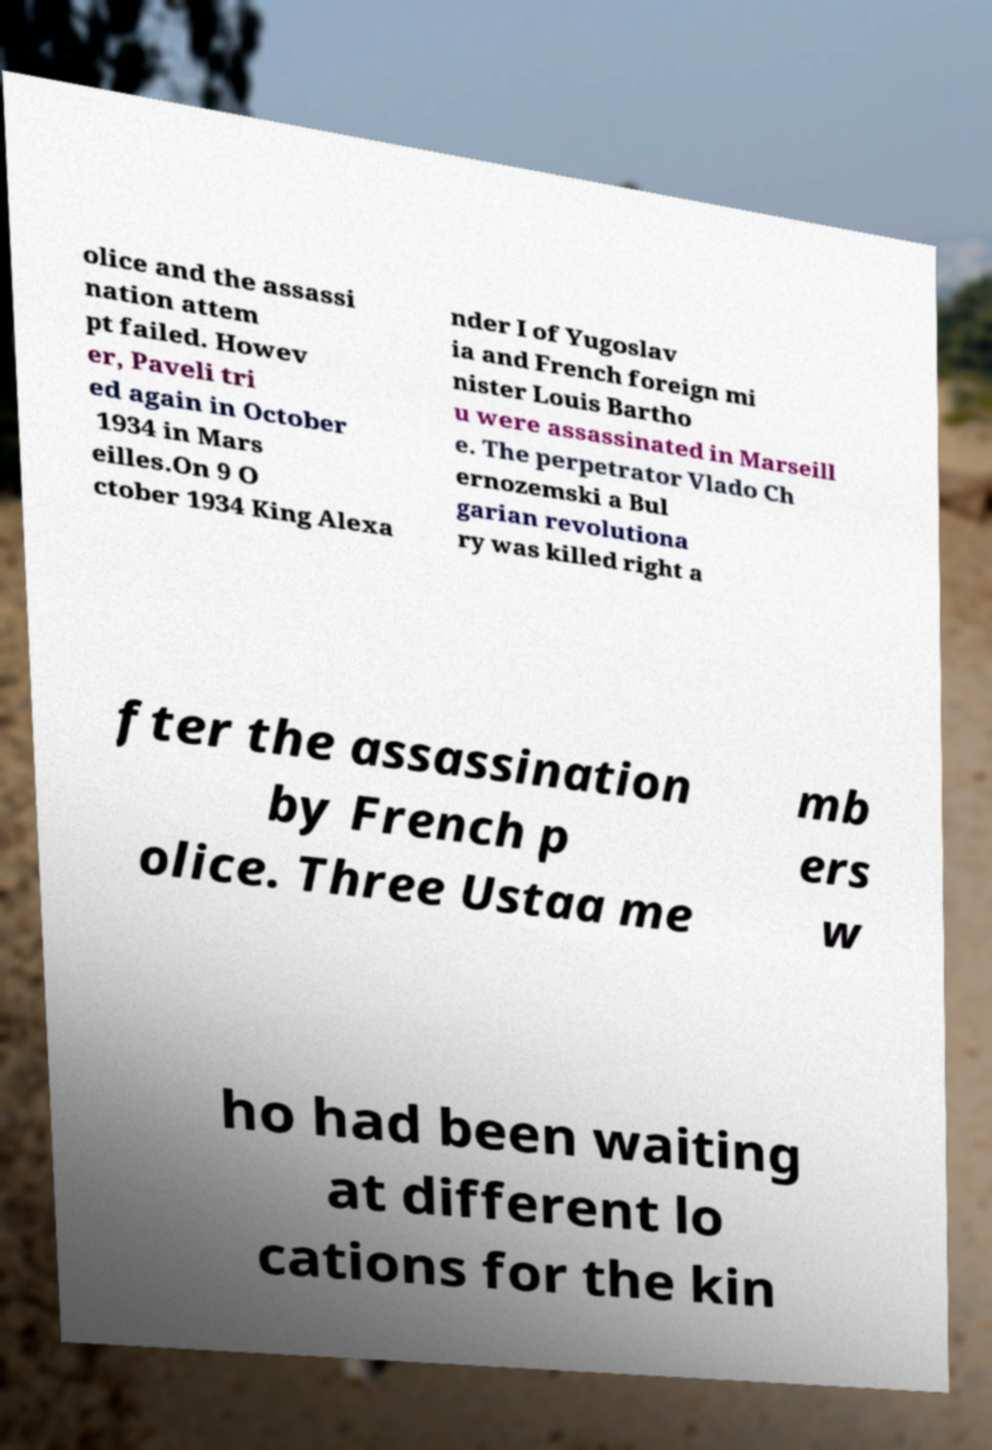For documentation purposes, I need the text within this image transcribed. Could you provide that? olice and the assassi nation attem pt failed. Howev er, Paveli tri ed again in October 1934 in Mars eilles.On 9 O ctober 1934 King Alexa nder I of Yugoslav ia and French foreign mi nister Louis Bartho u were assassinated in Marseill e. The perpetrator Vlado Ch ernozemski a Bul garian revolutiona ry was killed right a fter the assassination by French p olice. Three Ustaa me mb ers w ho had been waiting at different lo cations for the kin 